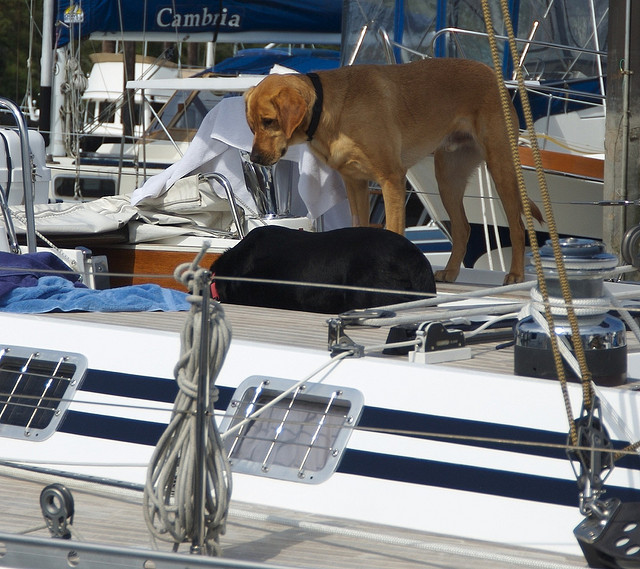<image>How many dogs are on the boat? I am not sure how many dogs are on the boat. The number could be either 1 or 2. How many dogs are on the boat? It is ambiguous how many dogs are on the boat. It can be seen 1 or 2. 